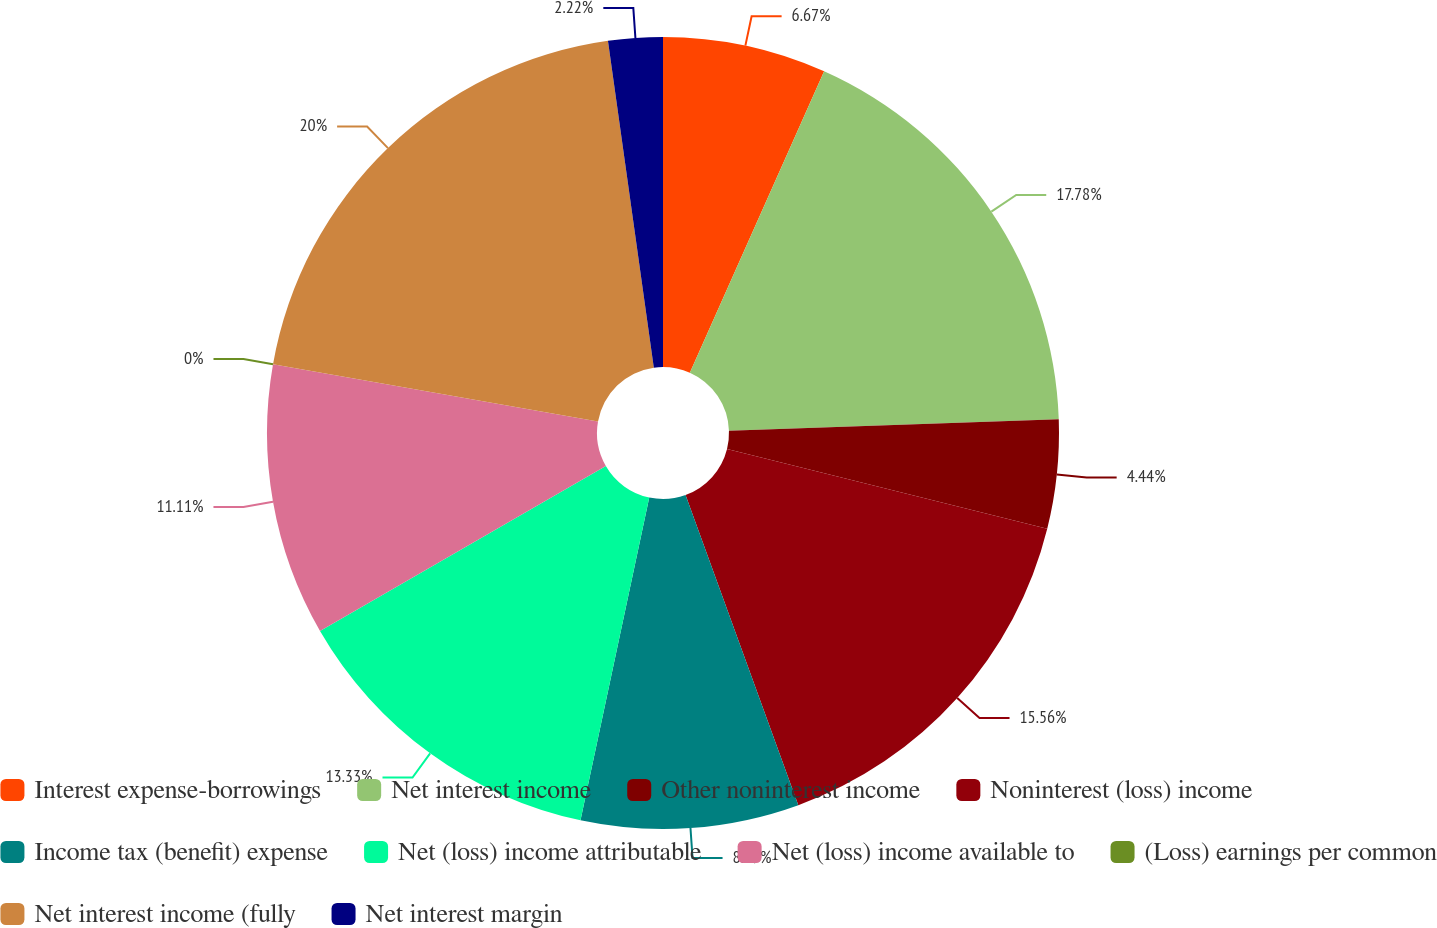Convert chart. <chart><loc_0><loc_0><loc_500><loc_500><pie_chart><fcel>Interest expense-borrowings<fcel>Net interest income<fcel>Other noninterest income<fcel>Noninterest (loss) income<fcel>Income tax (benefit) expense<fcel>Net (loss) income attributable<fcel>Net (loss) income available to<fcel>(Loss) earnings per common<fcel>Net interest income (fully<fcel>Net interest margin<nl><fcel>6.67%<fcel>17.78%<fcel>4.44%<fcel>15.56%<fcel>8.89%<fcel>13.33%<fcel>11.11%<fcel>0.0%<fcel>20.0%<fcel>2.22%<nl></chart> 